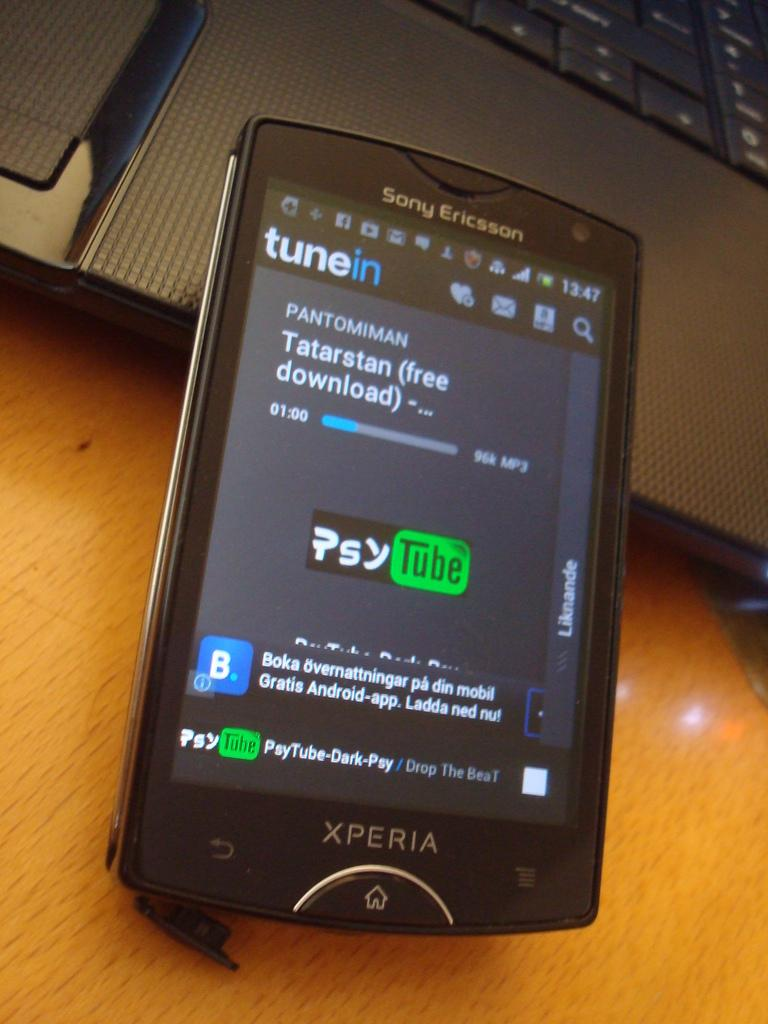What electronic device is visible in the image? There is a laptop in the image. What other electronic device can be seen in the image? There is a mobile phone in the image. What type of surface are the laptop and mobile phone placed on in the image? The laptop and mobile phone are placed on a wooden surface. What color is the orange in the image? There is no orange present in the image. How does the throat look in the image? There is no reference to a throat in the image. 